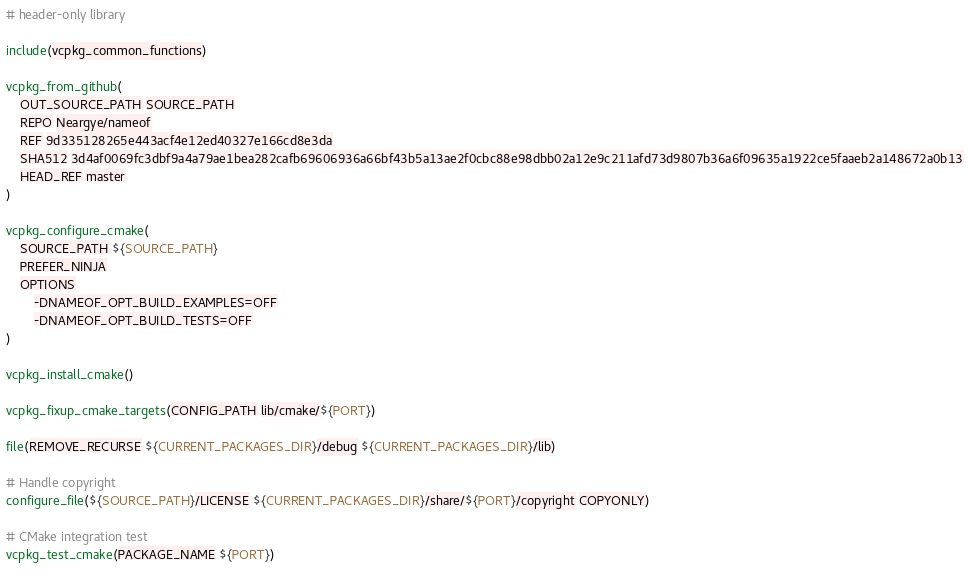Convert code to text. <code><loc_0><loc_0><loc_500><loc_500><_CMake_># header-only library

include(vcpkg_common_functions)

vcpkg_from_github(
    OUT_SOURCE_PATH SOURCE_PATH
    REPO Neargye/nameof
    REF 9d335128265e443acf4e12ed40327e166cd8e3da
    SHA512 3d4af0069fc3dbf9a4a79ae1bea282cafb69606936a66bf43b5a13ae2f0cbc88e98dbb02a12e9c211afd73d9807b36a6f09635a1922ce5faaeb2a148672a0b13
    HEAD_REF master
)

vcpkg_configure_cmake(
    SOURCE_PATH ${SOURCE_PATH}
    PREFER_NINJA
    OPTIONS
        -DNAMEOF_OPT_BUILD_EXAMPLES=OFF
        -DNAMEOF_OPT_BUILD_TESTS=OFF
)

vcpkg_install_cmake()

vcpkg_fixup_cmake_targets(CONFIG_PATH lib/cmake/${PORT})

file(REMOVE_RECURSE ${CURRENT_PACKAGES_DIR}/debug ${CURRENT_PACKAGES_DIR}/lib)

# Handle copyright
configure_file(${SOURCE_PATH}/LICENSE ${CURRENT_PACKAGES_DIR}/share/${PORT}/copyright COPYONLY)

# CMake integration test
vcpkg_test_cmake(PACKAGE_NAME ${PORT})
</code> 